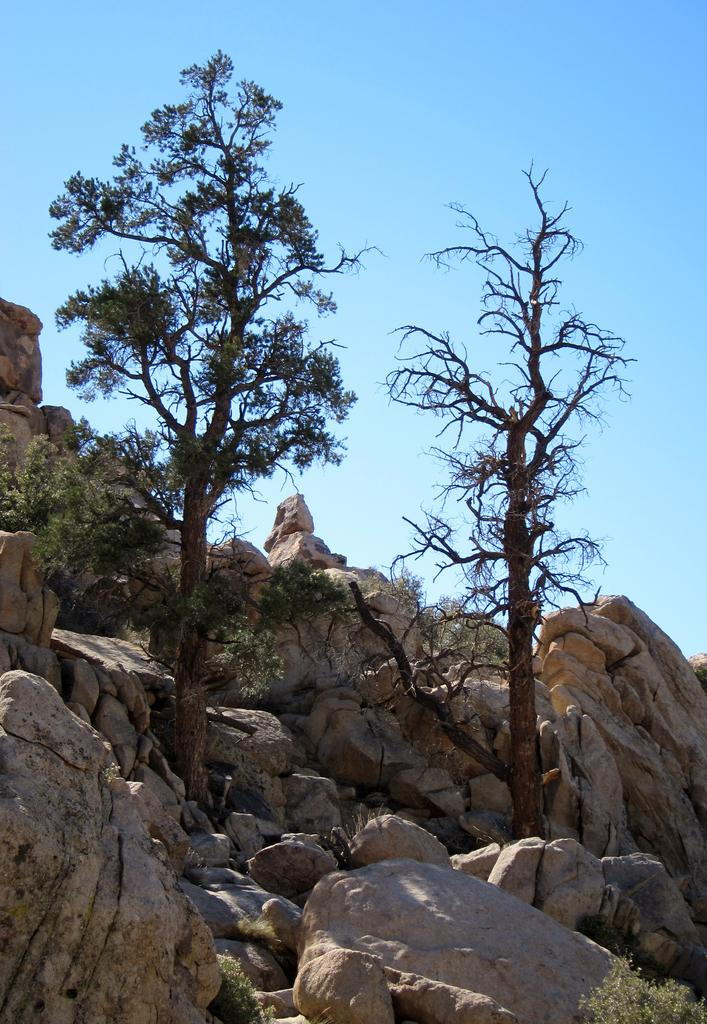What type of natural elements can be seen in the image? There are rocks and trees in the image. What is the color and condition of the sky in the image? The sky is blue and cloudy in the image. What type of lace is draped over the rocks in the image? There is no lace present in the image; it only features rocks, trees, and a blue, cloudy sky. 